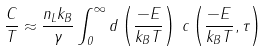<formula> <loc_0><loc_0><loc_500><loc_500>\frac { C } { T } \approx \frac { n _ { L } k _ { B } } { \gamma } \int _ { 0 } ^ { \infty } d \left ( \frac { - E } { k _ { B } T } \right ) \, c \left ( \frac { - E } { k _ { B } T } , \tau \right )</formula> 